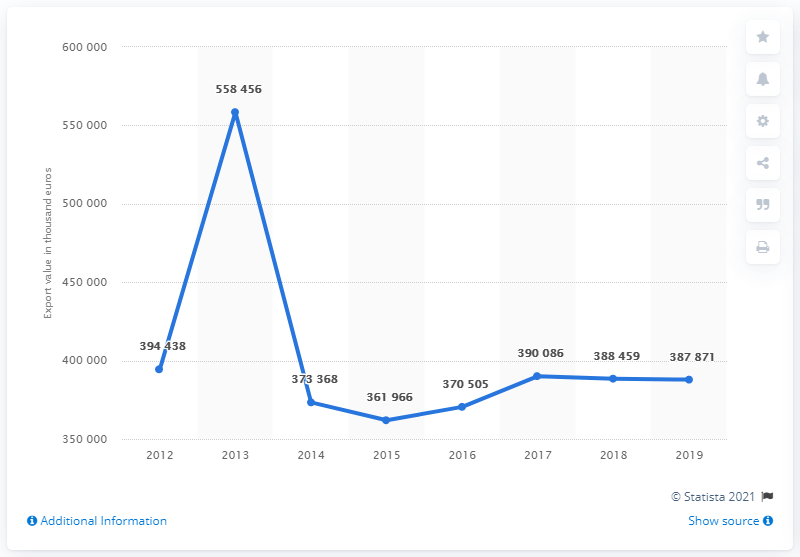Identify some key points in this picture. The export value of sunflower seeds from Bulgaria from 2012 to 2019 was 387,871 metric tons. 